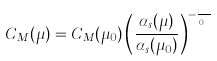Convert formula to latex. <formula><loc_0><loc_0><loc_500><loc_500>C _ { M } ( \mu ) = C _ { M } ( \mu _ { 0 } ) \left ( \frac { \alpha _ { s } ( \mu ) } { \alpha _ { s } ( \mu _ { 0 } ) } \right ) ^ { - \frac { C _ { A } } { \beta _ { 0 } } }</formula> 